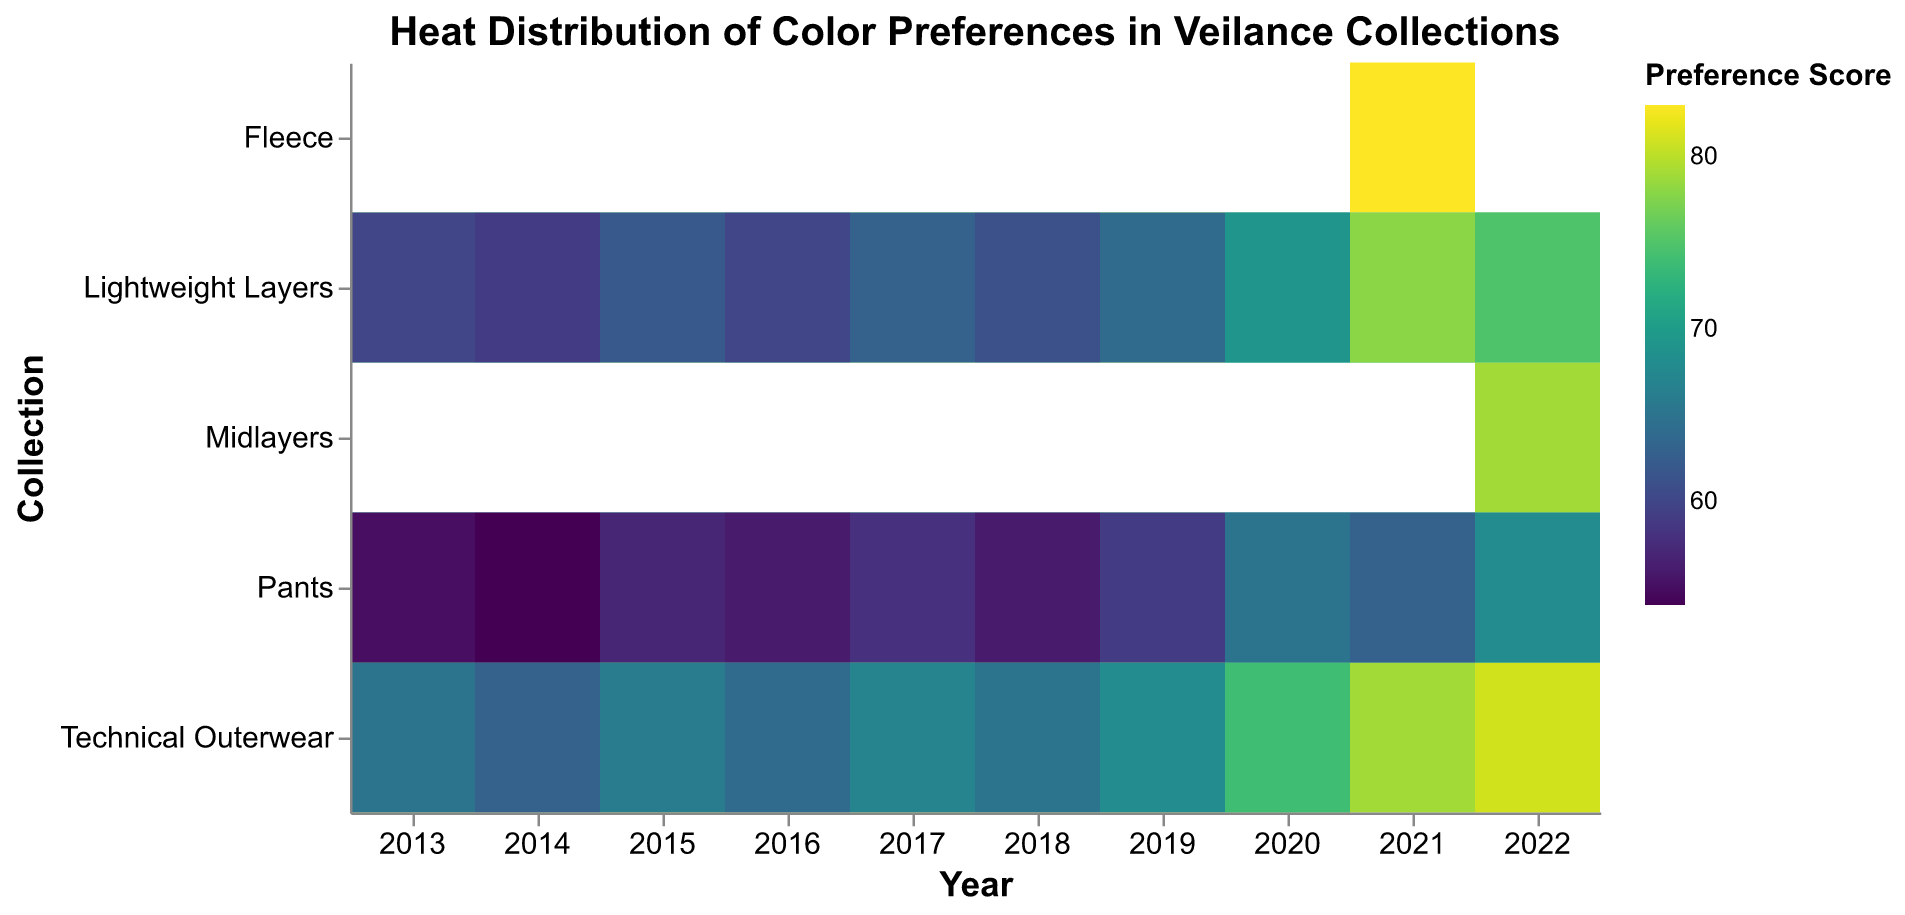Which year had the highest preference score for "Technical Outerwear" in Black? The figure visualizes the preference scores by color and year. Look for the "Technical Outerwear" row and Black color. The highest score in this row for Black is in 2019 with a score of 83.
Answer: 2019 What is the average preference score for "Pants" in the year 2013? Look for the scores in the year 2013 for "Pants" in all colors. The scores are 70 (Black) and 55 (Graphite). Calculate the average: (70 + 55) / 2 = 125 / 2 = 62.5.
Answer: 62.5 Which collection had the highest "Preference Score" in the year 2021? Check the year 2021 for all collection rows. The highest score in 2021 is for the "Fleece" collection, with a score of 83 in Lunar.
Answer: Fleece How does the preference score for "Graphite" in "Lightweight Layers" change from 2013 to 2020? Observe the "Lightweight Layers" row for Graphite from 2013 to 2020. The scores are: 60 (2013), 59 (2014), 62 (2015), 60 (2016), 63 (2017), 61 (2018), 64 (2019), 69 (2020). The score increases from 60 to 69 over this period.
Answer: The score increased from 60 to 69 Which color in the "Technical Outerwear" collection had the highest average preference score across all years? Calculate the average score for each color in "Technical Outerwear" by summing the scores for each year and dividing by the number of years. Black: (80 + 78 + 81 + 79 + 82 + 80 + 83 + 77 + 79 + 81) / 10 = 800 / 10 = 80. Obsidian and Lunar have fewer years due to later introduction. The highest average is 80 for Black.
Answer: Black What were the preference scores for "Obsidian" in the "Pants" collection in 2020 and 2021, and what is their average? Check the "Pants" collection row for Obsidian in 2020 and 2021. The scores are 67 (2020) and 69 (2021). Calculate the average: (67 + 69) / 2 = 68.
Answer: 68 Compare the preference score trends of "Technical Outerwear" in Black and Graphite from 2013 to 2019. For Black: 80 (2013), 78 (2014), 81 (2015), 79 (2016), 82 (2017), 80 (2018), 83 (2019). For Graphite: 65 (2013), 63 (2014), 66 (2015), 64 (2016), 67 (2017), 65 (2018), 68 (2019). Trend: Black shows a general increase with some fluctuations, while Graphite has a slower, more gradual increase.
Answer: Black increased more rapidly than Graphite Which year introduced the "Lunar" color and in which collections? Identify the first appearance of "Lunar" in the figure. It appears in 2021 for "Fleece," "Lightweight Layers," and "Pants".
Answer: 2021 for Fleece, Lightweight Layers, and Pants What is the highest preference score for "Obsidian" in "Lightweight Layers"? Check the preference scores for "Obsidian" in the "Lightweight Layers" row across all years. The highest score is 76 in 2022.
Answer: 76 Which collection had the most diverse color preference scores in 2021? Check the preference scores for all collections in 2021. "Pants" has scores in three colors: 69 (Obsidian), 63 (Lunar), making it the most diverse in color preference scores.
Answer: Pants 